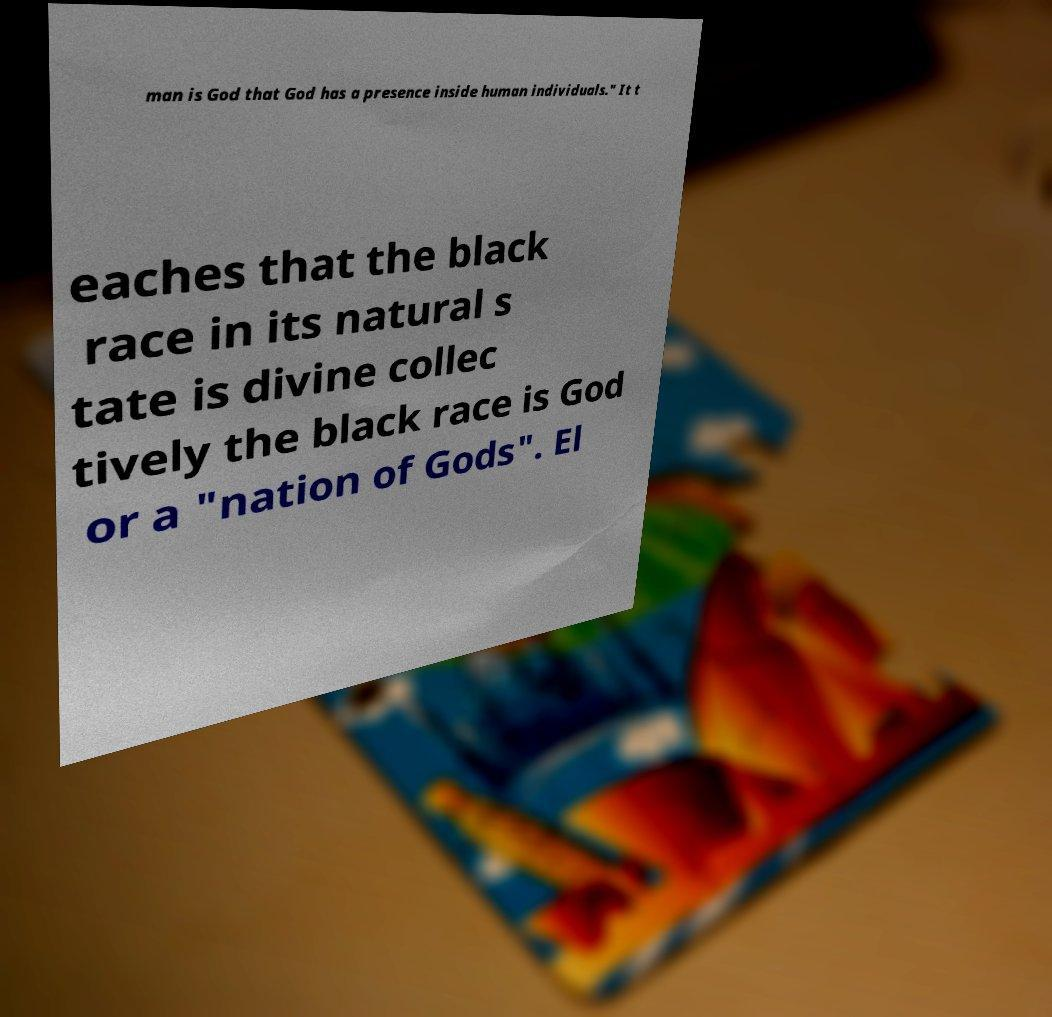Can you accurately transcribe the text from the provided image for me? man is God that God has a presence inside human individuals." It t eaches that the black race in its natural s tate is divine collec tively the black race is God or a "nation of Gods". El 